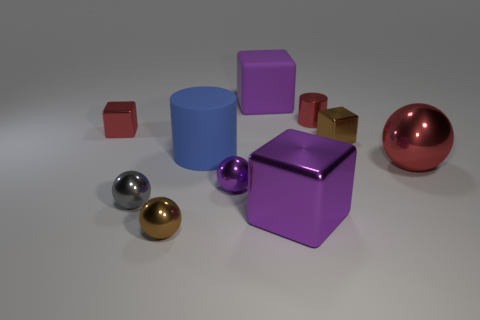Subtract all spheres. How many objects are left? 6 Subtract 0 cyan balls. How many objects are left? 10 Subtract all big blue cylinders. Subtract all small balls. How many objects are left? 6 Add 7 small gray objects. How many small gray objects are left? 8 Add 8 red spheres. How many red spheres exist? 9 